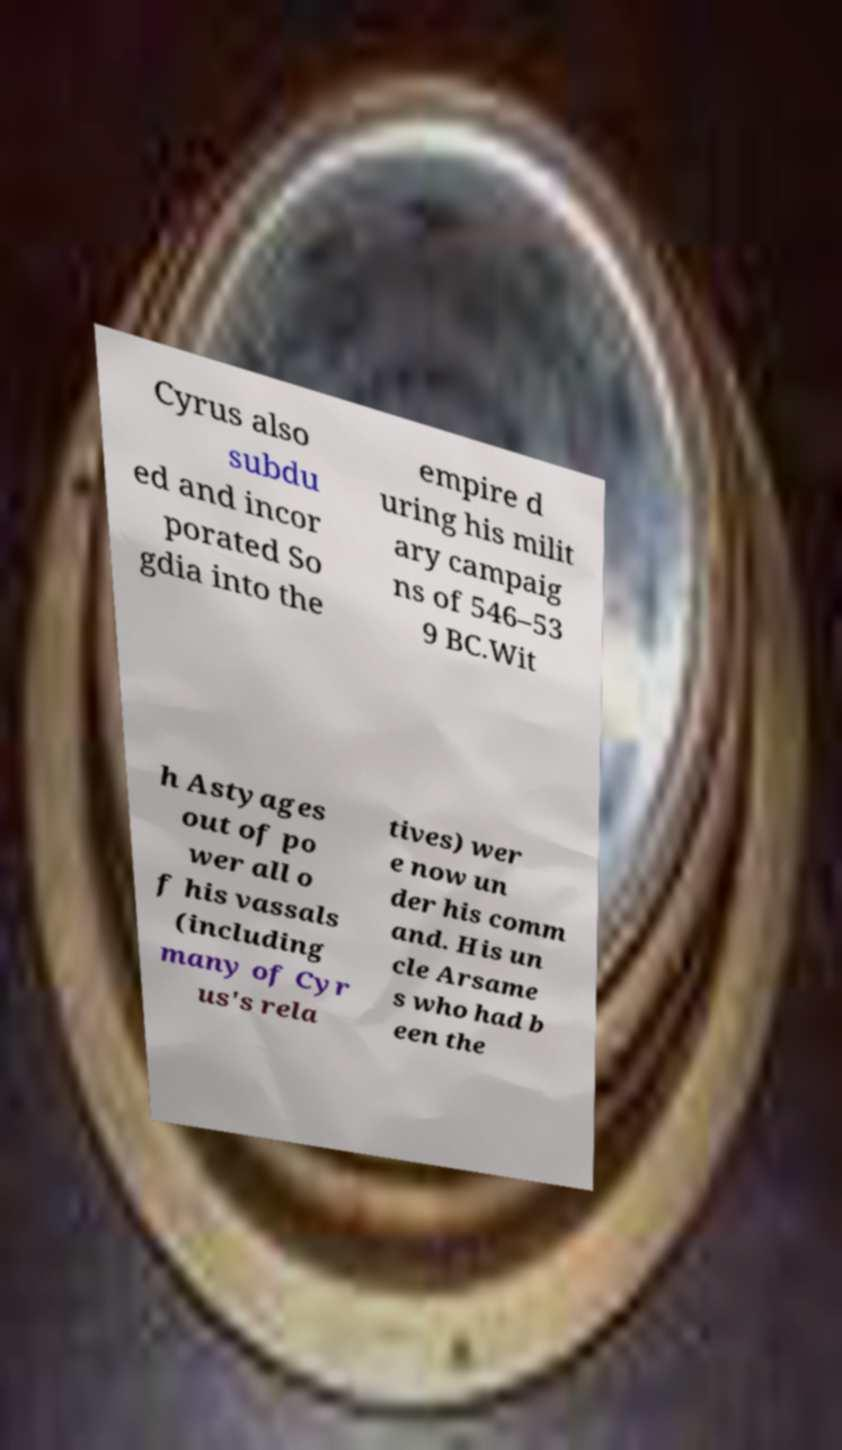What messages or text are displayed in this image? I need them in a readable, typed format. Cyrus also subdu ed and incor porated So gdia into the empire d uring his milit ary campaig ns of 546–53 9 BC.Wit h Astyages out of po wer all o f his vassals (including many of Cyr us's rela tives) wer e now un der his comm and. His un cle Arsame s who had b een the 